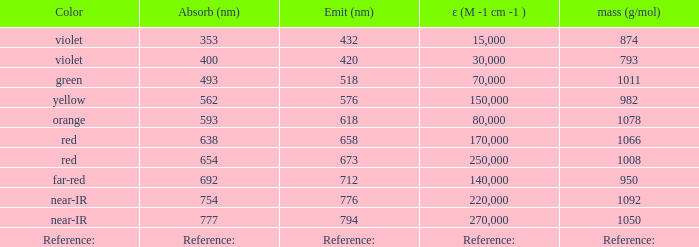Which Emission (in nanometers) has an absorbtion of 593 nm? 618.0. 